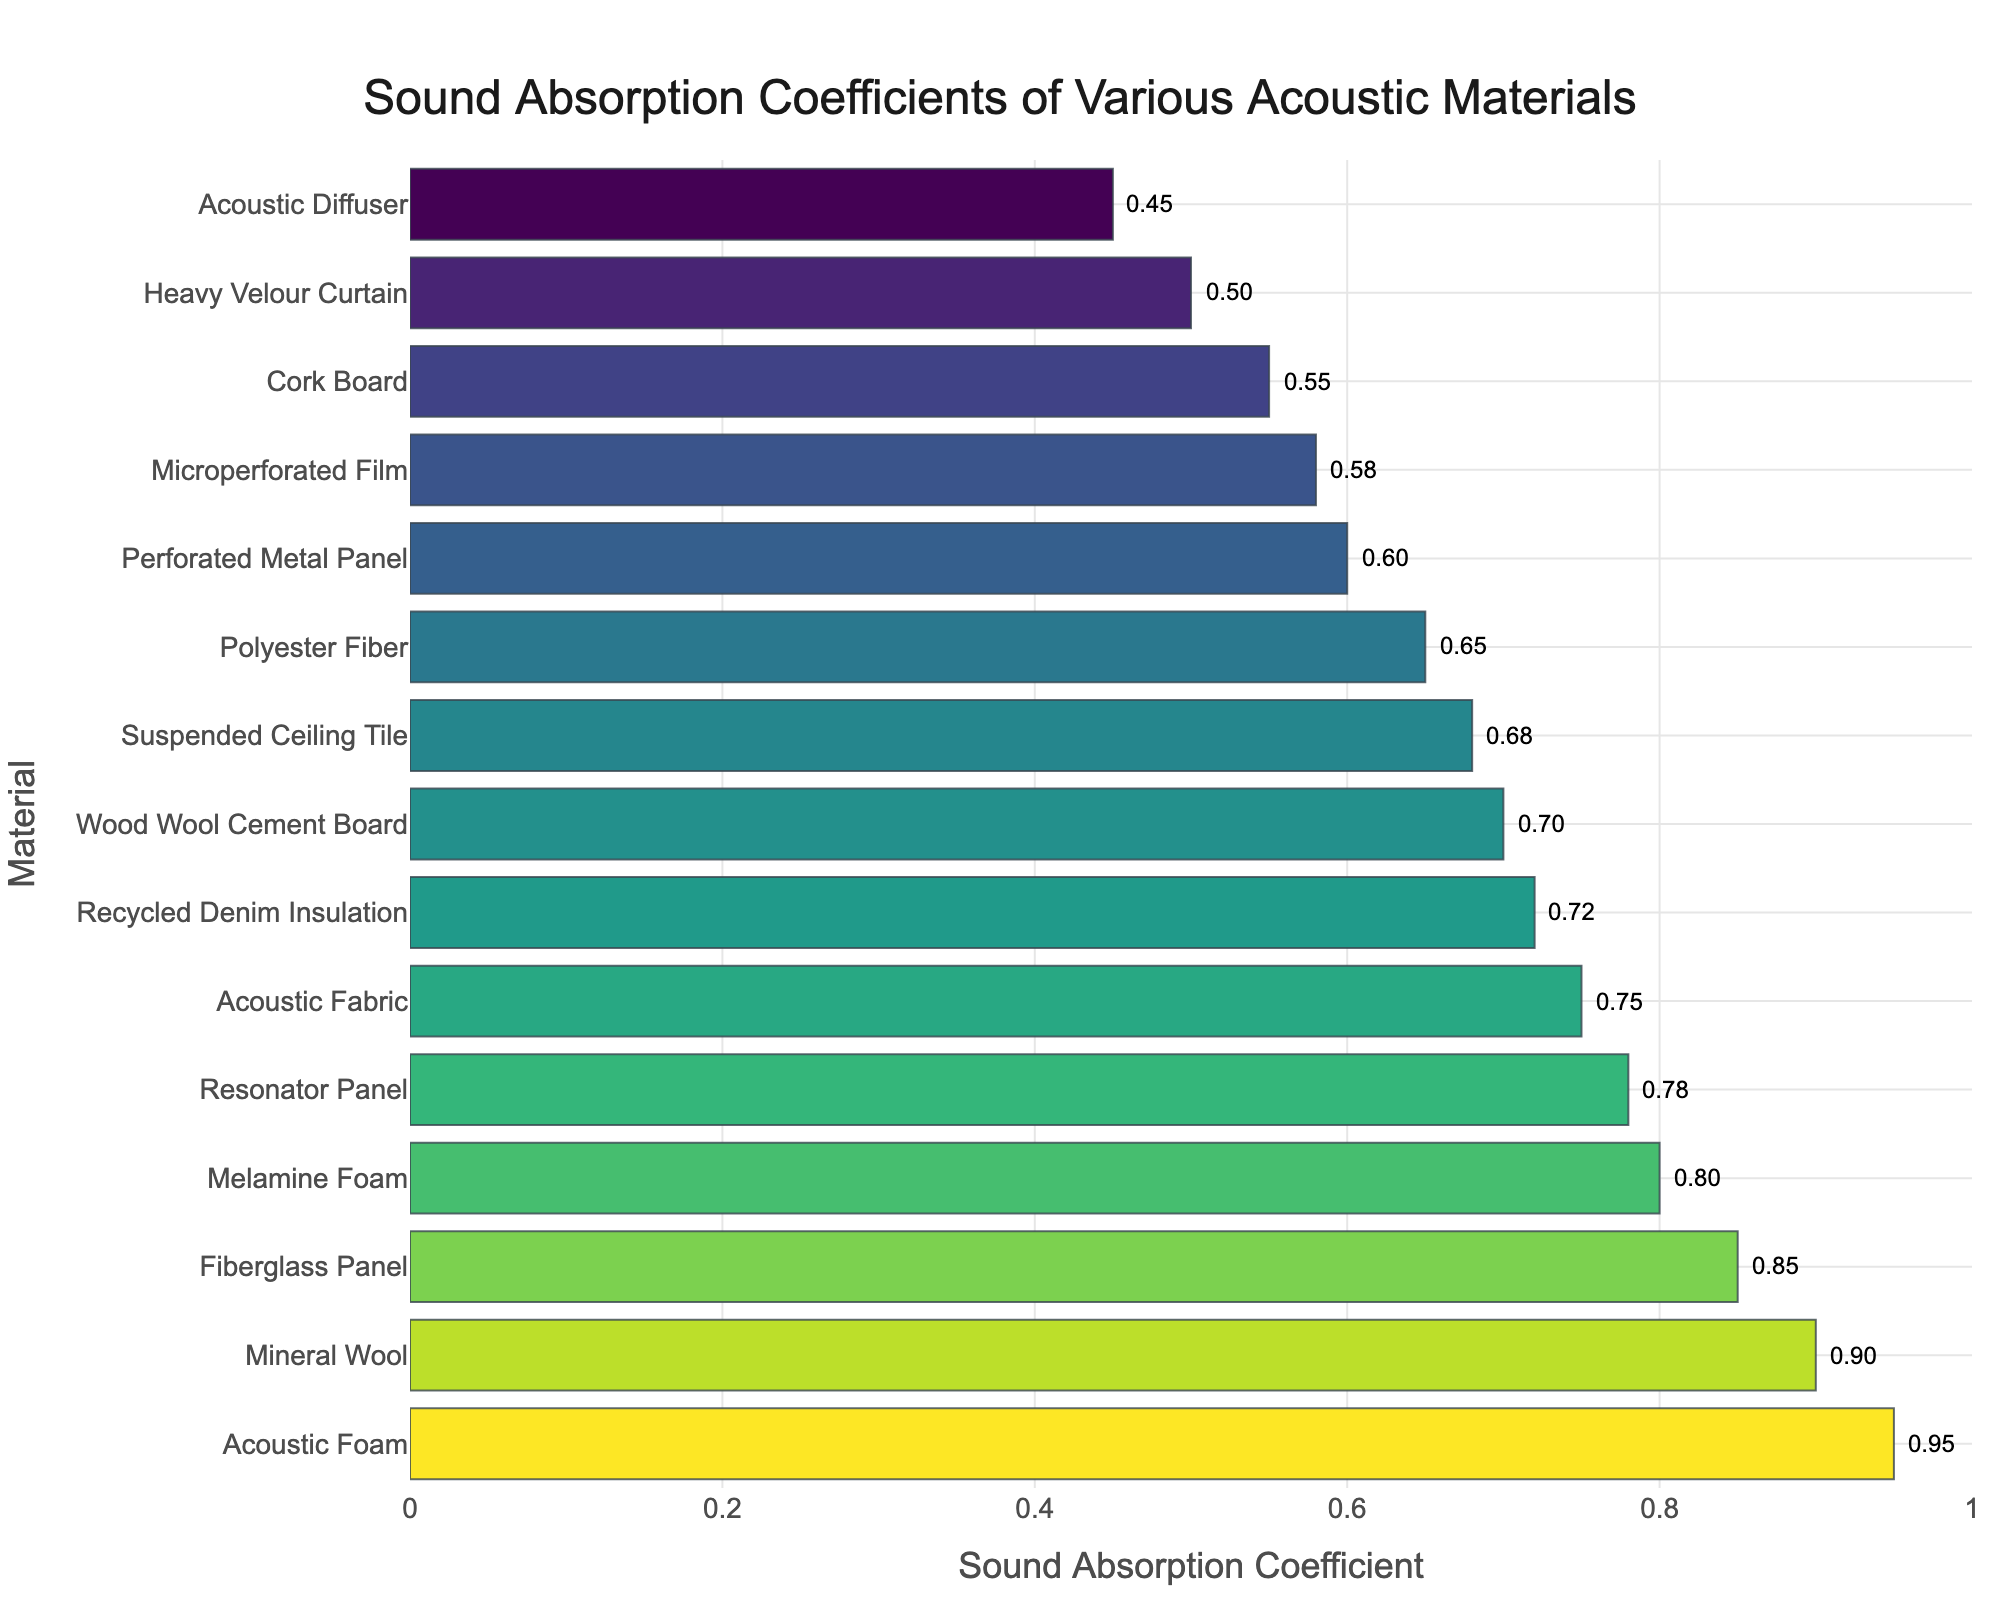Which material has the highest sound absorption coefficient? The bar representing Acoustic Foam is the longest, and its value is 0.95.
Answer: Acoustic Foam Which material has the lowest sound absorption coefficient? The bar representing Acoustic Diffuser is the shortest, and its value is 0.45.
Answer: Acoustic Diffuser What is the difference in sound absorption coefficient between Acoustic Foam and Mineral Wool? The coefficient for Acoustic Foam is 0.95 and for Mineral Wool is 0.90. The difference is 0.95 - 0.90 = 0.05.
Answer: 0.05 Which materials have a sound absorption coefficient greater than 0.75? The materials with bars extending past 0.75 are Acoustic Foam, Mineral Wool, Fiberglass Panel, and Resonator Panel.
Answer: Acoustic Foam, Mineral Wool, Fiberglass Panel, Resonator Panel What is the average sound absorption coefficient of Acoustic Foam, Fiberglass Panel, and Mineral Wool? The coefficients are 0.95, 0.85, and 0.90 respectively. The average is (0.95 + 0.85 + 0.90) / 3 = 0.9.
Answer: 0.9 Which material’s bar is closer in height to Acoustic Foam's bar, Mineral Wool or Fiberglass Panel? The coefficients are 0.95 for Acoustic Foam, 0.90 for Mineral Wool, and 0.85 for Fiberglass Panel. The difference from Acoustic Foam is 0.05 for Mineral Wool and 0.10 for Fiberglass Panel.
Answer: Mineral Wool Is there a material with a sound absorption coefficient equal to or higher than 0.80 but lower than 0.90? The materials fitting this criteria are Melamine Foam (0.80) and Resonator Panel (0.78).
Answer: Melamine Foam, Resonator Panel How many materials have a sound absorption coefficient less than or equal to 0.60? The materials with coefficients ≤ 0.60 are Perforated Metal Panel (0.60), Cork Board (0.55), Microperforated Film (0.58), Heavy Velour Curtain (0.50), and Acoustic Diffuser (0.45). There are 5 of these materials.
Answer: 5 What is the total sound absorption coefficient for Acoustic Fabric, Cork Board, and Heavy Velour Curtain combined? The coefficients are 0.75, 0.55, and 0.50 respectively. The total is 0.75 + 0.55 + 0.50 = 1.80.
Answer: 1.80 